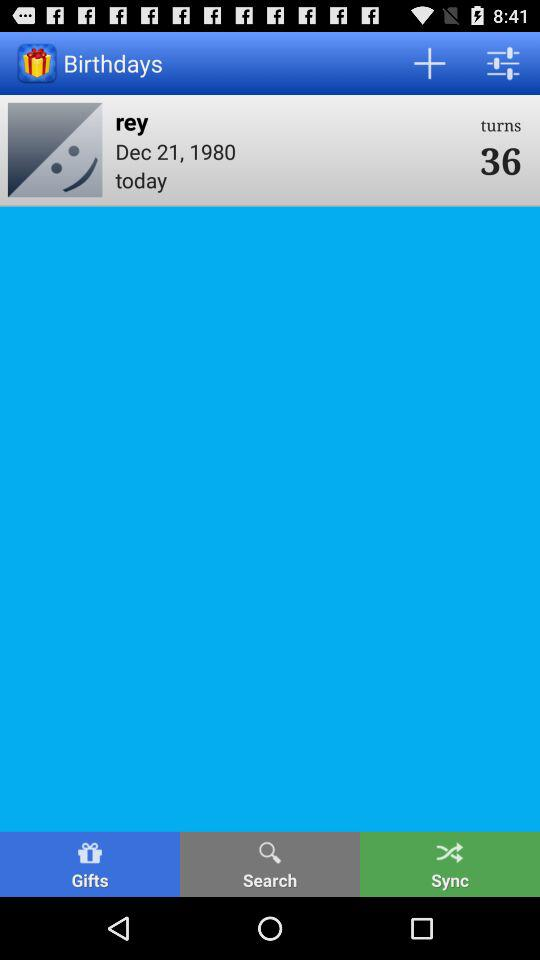How many years older is Rey than the year she was born?
Answer the question using a single word or phrase. 36 